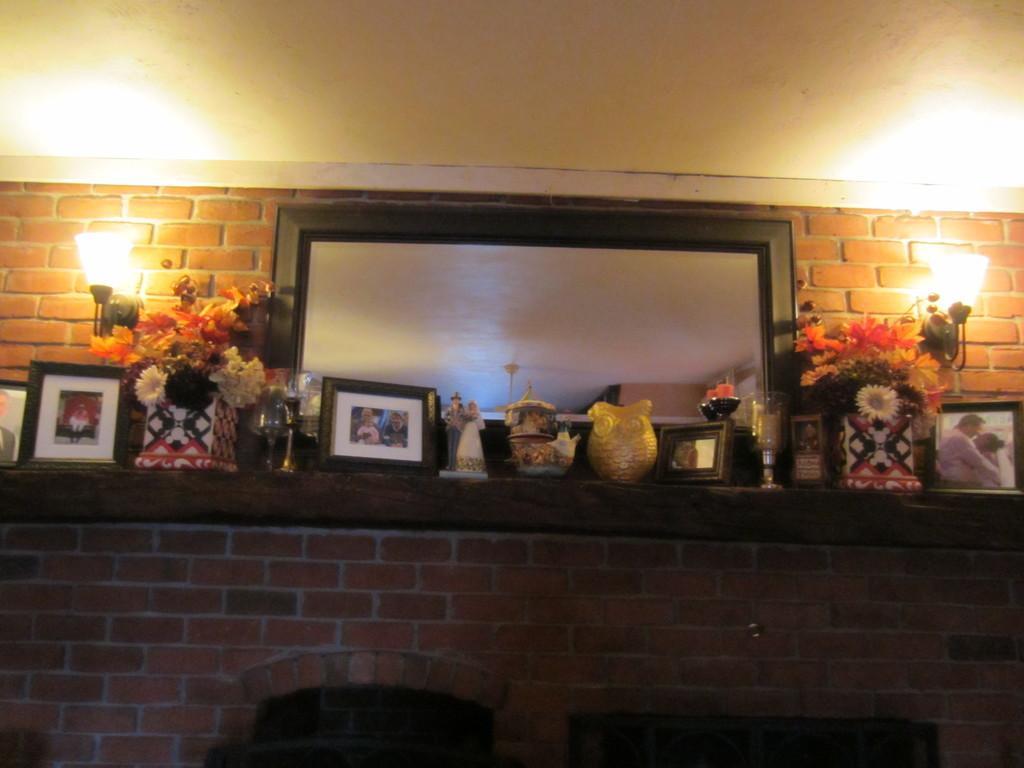Could you give a brief overview of what you see in this image? In this picture, we can see the wall, and some objects on the wall like, photo frames, jars, flowers, toys, and we can see some lights, and the roof. 